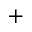<formula> <loc_0><loc_0><loc_500><loc_500>+</formula> 